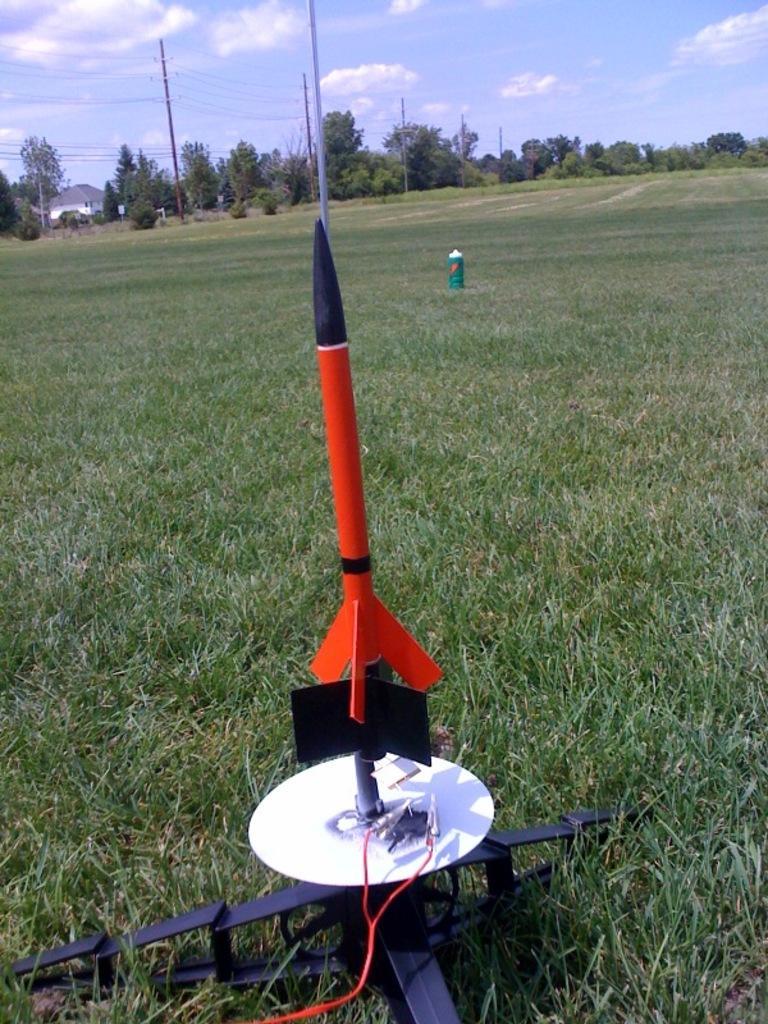Can you describe this image briefly? Front we can see a rocket. Land is covered with grass. Far there are trees, current poles and house. 